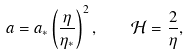<formula> <loc_0><loc_0><loc_500><loc_500>a = a _ { * } \left ( \frac { \eta } { \eta _ { * } } \right ) ^ { 2 } , \quad \mathcal { H } = \frac { 2 } { \eta } ,</formula> 